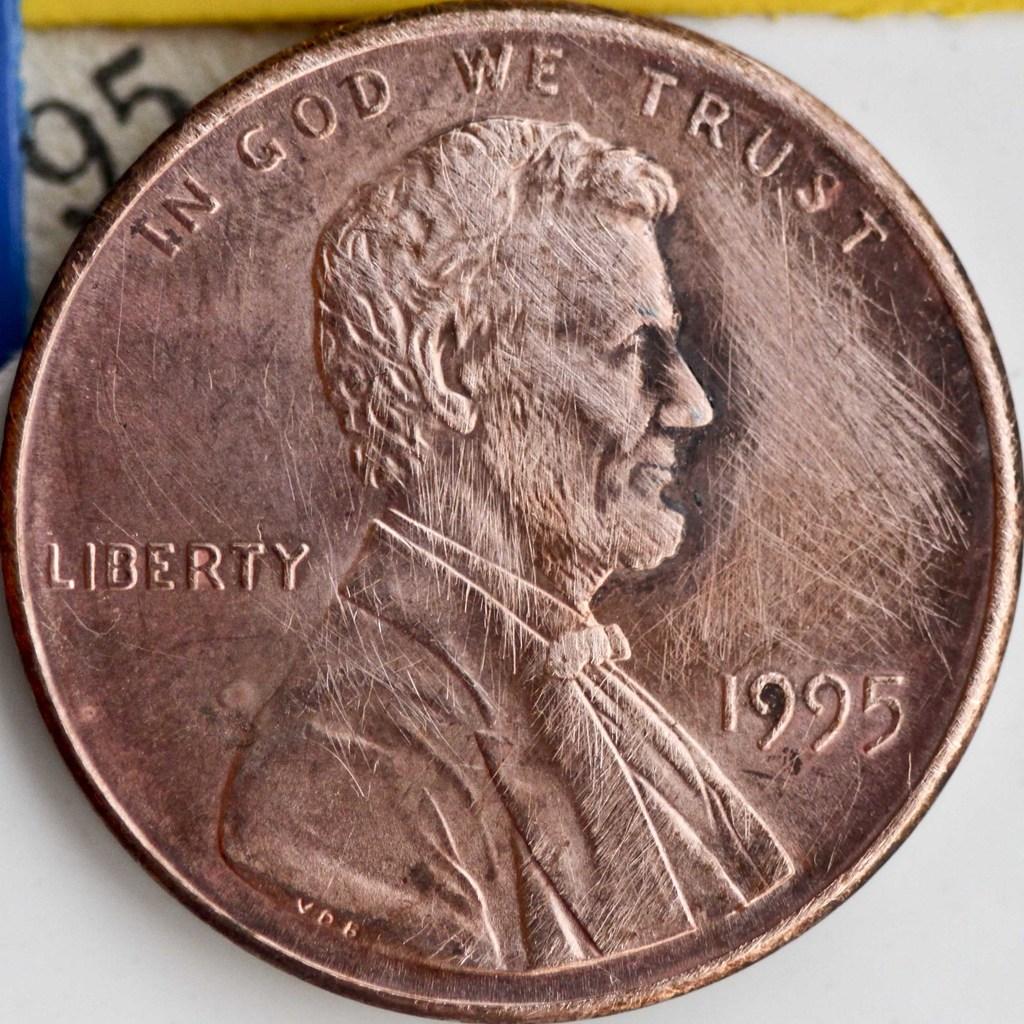What year was this penny made?
Your response must be concise. 1995. What is the slogan on the top of the penny?
Provide a short and direct response. In god we trust. 